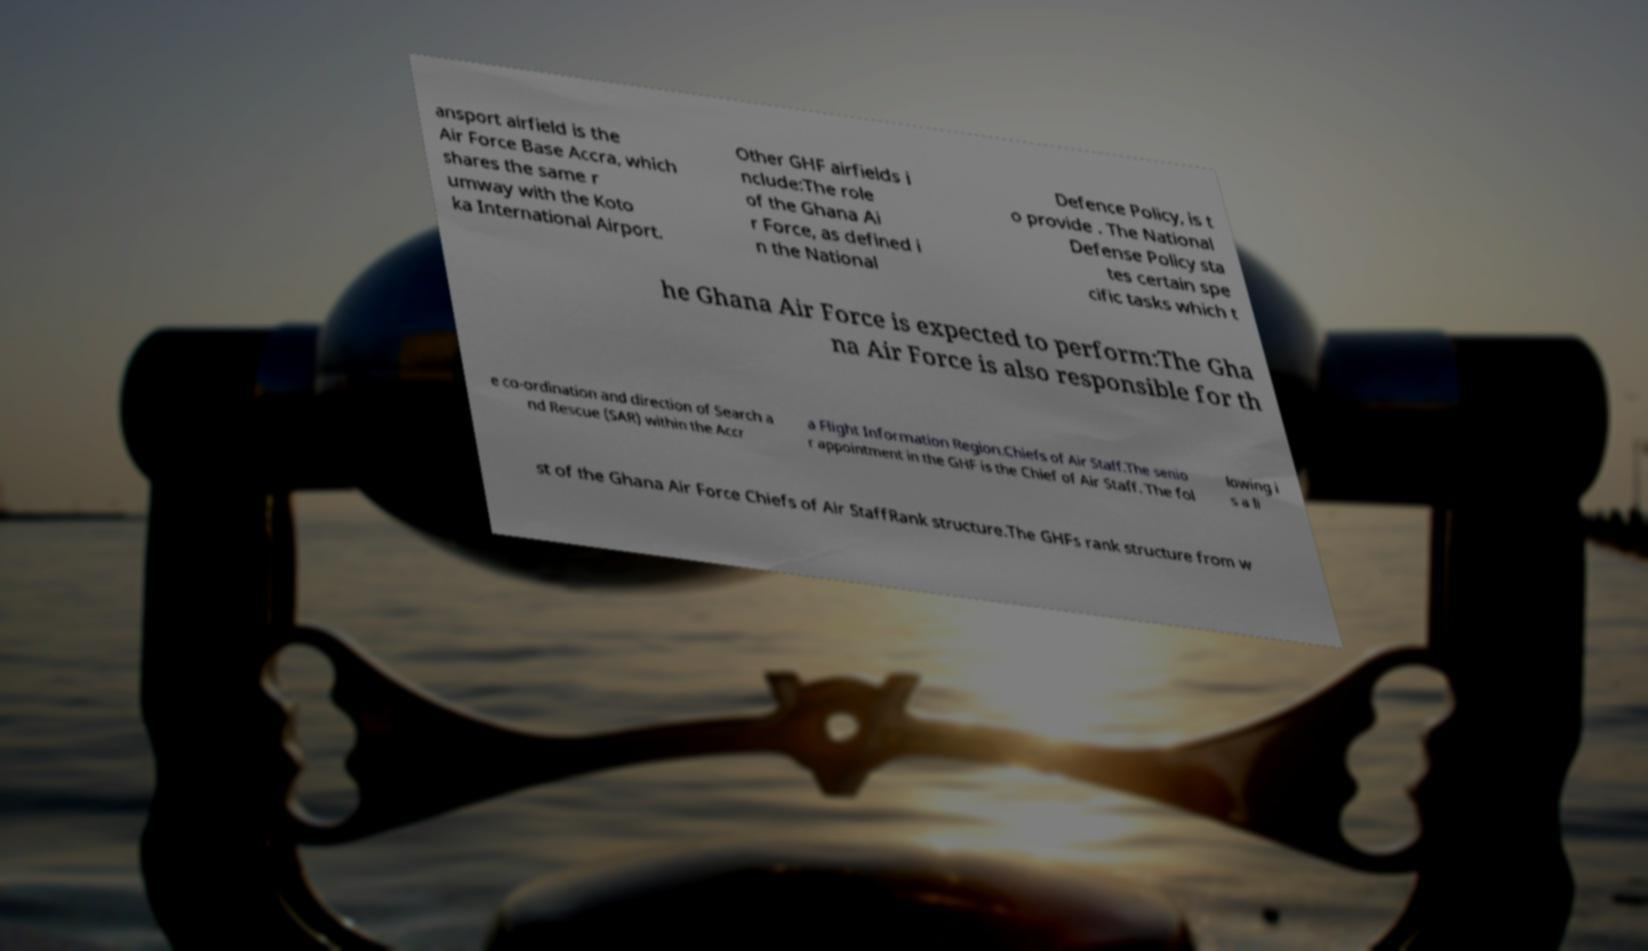What messages or text are displayed in this image? I need them in a readable, typed format. ansport airfield is the Air Force Base Accra, which shares the same r umway with the Koto ka International Airport. Other GHF airfields i nclude:The role of the Ghana Ai r Force, as defined i n the National Defence Policy, is t o provide . The National Defense Policy sta tes certain spe cific tasks which t he Ghana Air Force is expected to perform:The Gha na Air Force is also responsible for th e co-ordination and direction of Search a nd Rescue (SAR) within the Accr a Flight Information Region.Chiefs of Air Staff.The senio r appointment in the GHF is the Chief of Air Staff. The fol lowing i s a li st of the Ghana Air Force Chiefs of Air StaffRank structure.The GHFs rank structure from w 